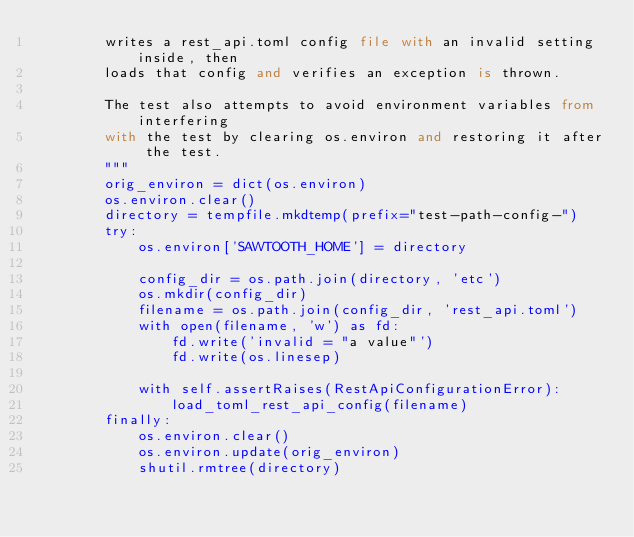Convert code to text. <code><loc_0><loc_0><loc_500><loc_500><_Python_>        writes a rest_api.toml config file with an invalid setting inside, then
        loads that config and verifies an exception is thrown.

        The test also attempts to avoid environment variables from interfering
        with the test by clearing os.environ and restoring it after the test.
        """
        orig_environ = dict(os.environ)
        os.environ.clear()
        directory = tempfile.mkdtemp(prefix="test-path-config-")
        try:
            os.environ['SAWTOOTH_HOME'] = directory

            config_dir = os.path.join(directory, 'etc')
            os.mkdir(config_dir)
            filename = os.path.join(config_dir, 'rest_api.toml')
            with open(filename, 'w') as fd:
                fd.write('invalid = "a value"')
                fd.write(os.linesep)

            with self.assertRaises(RestApiConfigurationError):
                load_toml_rest_api_config(filename)
        finally:
            os.environ.clear()
            os.environ.update(orig_environ)
            shutil.rmtree(directory)
</code> 